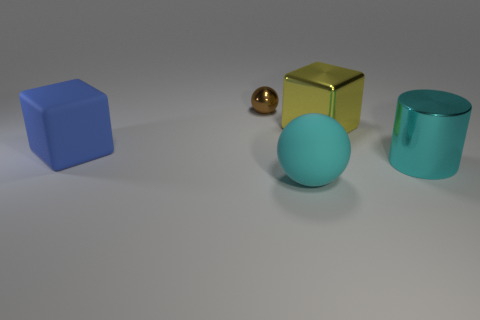How do the objects’ sizes compare to each other? In relation to each other, the turquoise cylinder is the tallest object, followed by the blue and gold cubes which are about the same size. The spherical objects, both the small metal one and the larger turquoise one, are on the smaller scale with the metal sphere being the smallest item displayed.  Could you use these objects to explain the concept of volume? Certainly! Volume is a measure of the amount of space an object occupies. The turquoise cylinder and the cubes have definable volumes, as each has a unique height, depth, and width that can be measured to calculate their volume. The spheres' volumes could also be determined since they have a uniform radius. Comparing these objects could provide practical examples for understanding how volume can vary between different shapes. 